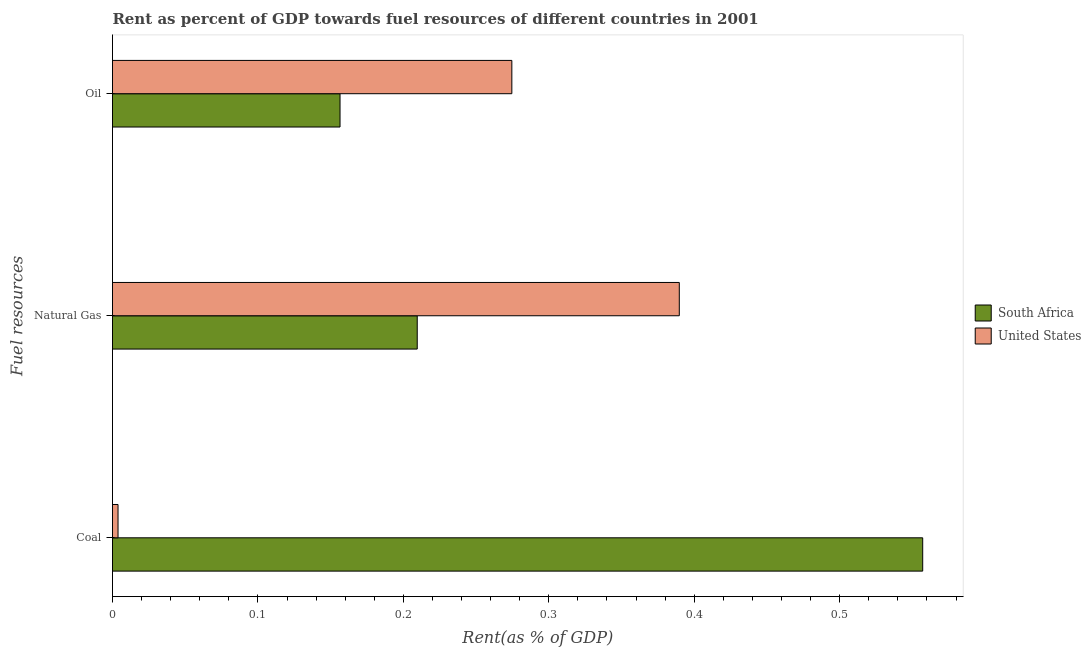How many different coloured bars are there?
Provide a succinct answer. 2. How many bars are there on the 3rd tick from the top?
Offer a terse response. 2. What is the label of the 2nd group of bars from the top?
Offer a very short reply. Natural Gas. What is the rent towards coal in United States?
Keep it short and to the point. 0. Across all countries, what is the maximum rent towards coal?
Give a very brief answer. 0.56. Across all countries, what is the minimum rent towards natural gas?
Provide a short and direct response. 0.21. In which country was the rent towards coal maximum?
Give a very brief answer. South Africa. In which country was the rent towards natural gas minimum?
Provide a short and direct response. South Africa. What is the total rent towards coal in the graph?
Your response must be concise. 0.56. What is the difference between the rent towards coal in South Africa and that in United States?
Offer a terse response. 0.55. What is the difference between the rent towards coal in United States and the rent towards oil in South Africa?
Give a very brief answer. -0.15. What is the average rent towards oil per country?
Your response must be concise. 0.22. What is the difference between the rent towards oil and rent towards natural gas in South Africa?
Your answer should be very brief. -0.05. What is the ratio of the rent towards coal in United States to that in South Africa?
Make the answer very short. 0.01. What is the difference between the highest and the second highest rent towards coal?
Offer a terse response. 0.55. What is the difference between the highest and the lowest rent towards oil?
Offer a very short reply. 0.12. Is the sum of the rent towards coal in United States and South Africa greater than the maximum rent towards oil across all countries?
Keep it short and to the point. Yes. What does the 1st bar from the bottom in Coal represents?
Provide a short and direct response. South Africa. How many bars are there?
Give a very brief answer. 6. Are all the bars in the graph horizontal?
Offer a very short reply. Yes. How many countries are there in the graph?
Give a very brief answer. 2. What is the difference between two consecutive major ticks on the X-axis?
Keep it short and to the point. 0.1. Are the values on the major ticks of X-axis written in scientific E-notation?
Offer a terse response. No. Where does the legend appear in the graph?
Provide a succinct answer. Center right. How many legend labels are there?
Give a very brief answer. 2. What is the title of the graph?
Make the answer very short. Rent as percent of GDP towards fuel resources of different countries in 2001. What is the label or title of the X-axis?
Your answer should be very brief. Rent(as % of GDP). What is the label or title of the Y-axis?
Provide a succinct answer. Fuel resources. What is the Rent(as % of GDP) in South Africa in Coal?
Your answer should be very brief. 0.56. What is the Rent(as % of GDP) of United States in Coal?
Your answer should be compact. 0. What is the Rent(as % of GDP) in South Africa in Natural Gas?
Provide a succinct answer. 0.21. What is the Rent(as % of GDP) of United States in Natural Gas?
Give a very brief answer. 0.39. What is the Rent(as % of GDP) in South Africa in Oil?
Make the answer very short. 0.16. What is the Rent(as % of GDP) in United States in Oil?
Offer a very short reply. 0.27. Across all Fuel resources, what is the maximum Rent(as % of GDP) of South Africa?
Give a very brief answer. 0.56. Across all Fuel resources, what is the maximum Rent(as % of GDP) of United States?
Keep it short and to the point. 0.39. Across all Fuel resources, what is the minimum Rent(as % of GDP) in South Africa?
Your response must be concise. 0.16. Across all Fuel resources, what is the minimum Rent(as % of GDP) in United States?
Provide a short and direct response. 0. What is the total Rent(as % of GDP) of South Africa in the graph?
Keep it short and to the point. 0.92. What is the total Rent(as % of GDP) of United States in the graph?
Your answer should be very brief. 0.67. What is the difference between the Rent(as % of GDP) of South Africa in Coal and that in Natural Gas?
Your answer should be very brief. 0.35. What is the difference between the Rent(as % of GDP) in United States in Coal and that in Natural Gas?
Your response must be concise. -0.39. What is the difference between the Rent(as % of GDP) of South Africa in Coal and that in Oil?
Give a very brief answer. 0.4. What is the difference between the Rent(as % of GDP) in United States in Coal and that in Oil?
Your answer should be compact. -0.27. What is the difference between the Rent(as % of GDP) in South Africa in Natural Gas and that in Oil?
Make the answer very short. 0.05. What is the difference between the Rent(as % of GDP) in United States in Natural Gas and that in Oil?
Give a very brief answer. 0.12. What is the difference between the Rent(as % of GDP) of South Africa in Coal and the Rent(as % of GDP) of United States in Natural Gas?
Your answer should be very brief. 0.17. What is the difference between the Rent(as % of GDP) in South Africa in Coal and the Rent(as % of GDP) in United States in Oil?
Your answer should be very brief. 0.28. What is the difference between the Rent(as % of GDP) in South Africa in Natural Gas and the Rent(as % of GDP) in United States in Oil?
Make the answer very short. -0.07. What is the average Rent(as % of GDP) in South Africa per Fuel resources?
Provide a succinct answer. 0.31. What is the average Rent(as % of GDP) in United States per Fuel resources?
Keep it short and to the point. 0.22. What is the difference between the Rent(as % of GDP) of South Africa and Rent(as % of GDP) of United States in Coal?
Offer a terse response. 0.55. What is the difference between the Rent(as % of GDP) in South Africa and Rent(as % of GDP) in United States in Natural Gas?
Give a very brief answer. -0.18. What is the difference between the Rent(as % of GDP) in South Africa and Rent(as % of GDP) in United States in Oil?
Make the answer very short. -0.12. What is the ratio of the Rent(as % of GDP) of South Africa in Coal to that in Natural Gas?
Keep it short and to the point. 2.66. What is the ratio of the Rent(as % of GDP) in United States in Coal to that in Natural Gas?
Offer a very short reply. 0.01. What is the ratio of the Rent(as % of GDP) of South Africa in Coal to that in Oil?
Give a very brief answer. 3.56. What is the ratio of the Rent(as % of GDP) in United States in Coal to that in Oil?
Your response must be concise. 0.01. What is the ratio of the Rent(as % of GDP) in South Africa in Natural Gas to that in Oil?
Your response must be concise. 1.34. What is the ratio of the Rent(as % of GDP) in United States in Natural Gas to that in Oil?
Provide a short and direct response. 1.42. What is the difference between the highest and the second highest Rent(as % of GDP) of South Africa?
Ensure brevity in your answer.  0.35. What is the difference between the highest and the second highest Rent(as % of GDP) in United States?
Provide a succinct answer. 0.12. What is the difference between the highest and the lowest Rent(as % of GDP) in South Africa?
Offer a very short reply. 0.4. What is the difference between the highest and the lowest Rent(as % of GDP) of United States?
Give a very brief answer. 0.39. 